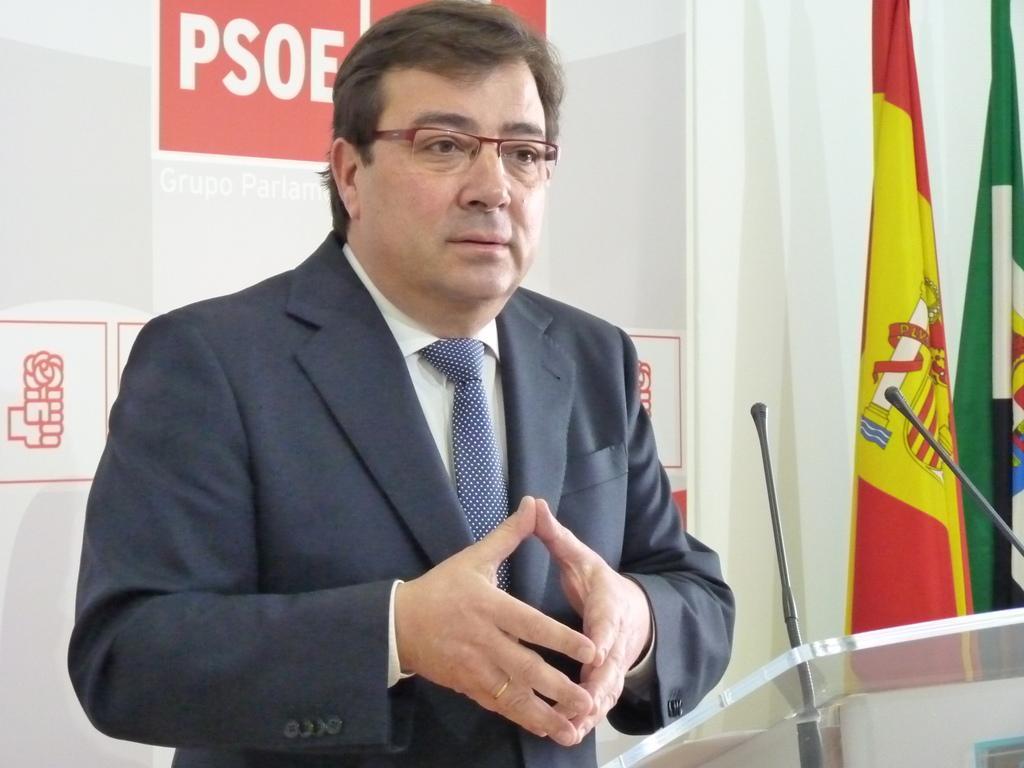Could you give a brief overview of what you see in this image? In the center of the image we can see a person standing at a desk. On the right side of the image we can see flags. In the background there is a wall. 